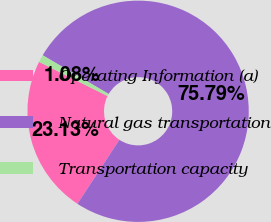Convert chart to OTSL. <chart><loc_0><loc_0><loc_500><loc_500><pie_chart><fcel>Operating Information (a)<fcel>Natural gas transportation<fcel>Transportation capacity<nl><fcel>23.13%<fcel>75.8%<fcel>1.08%<nl></chart> 